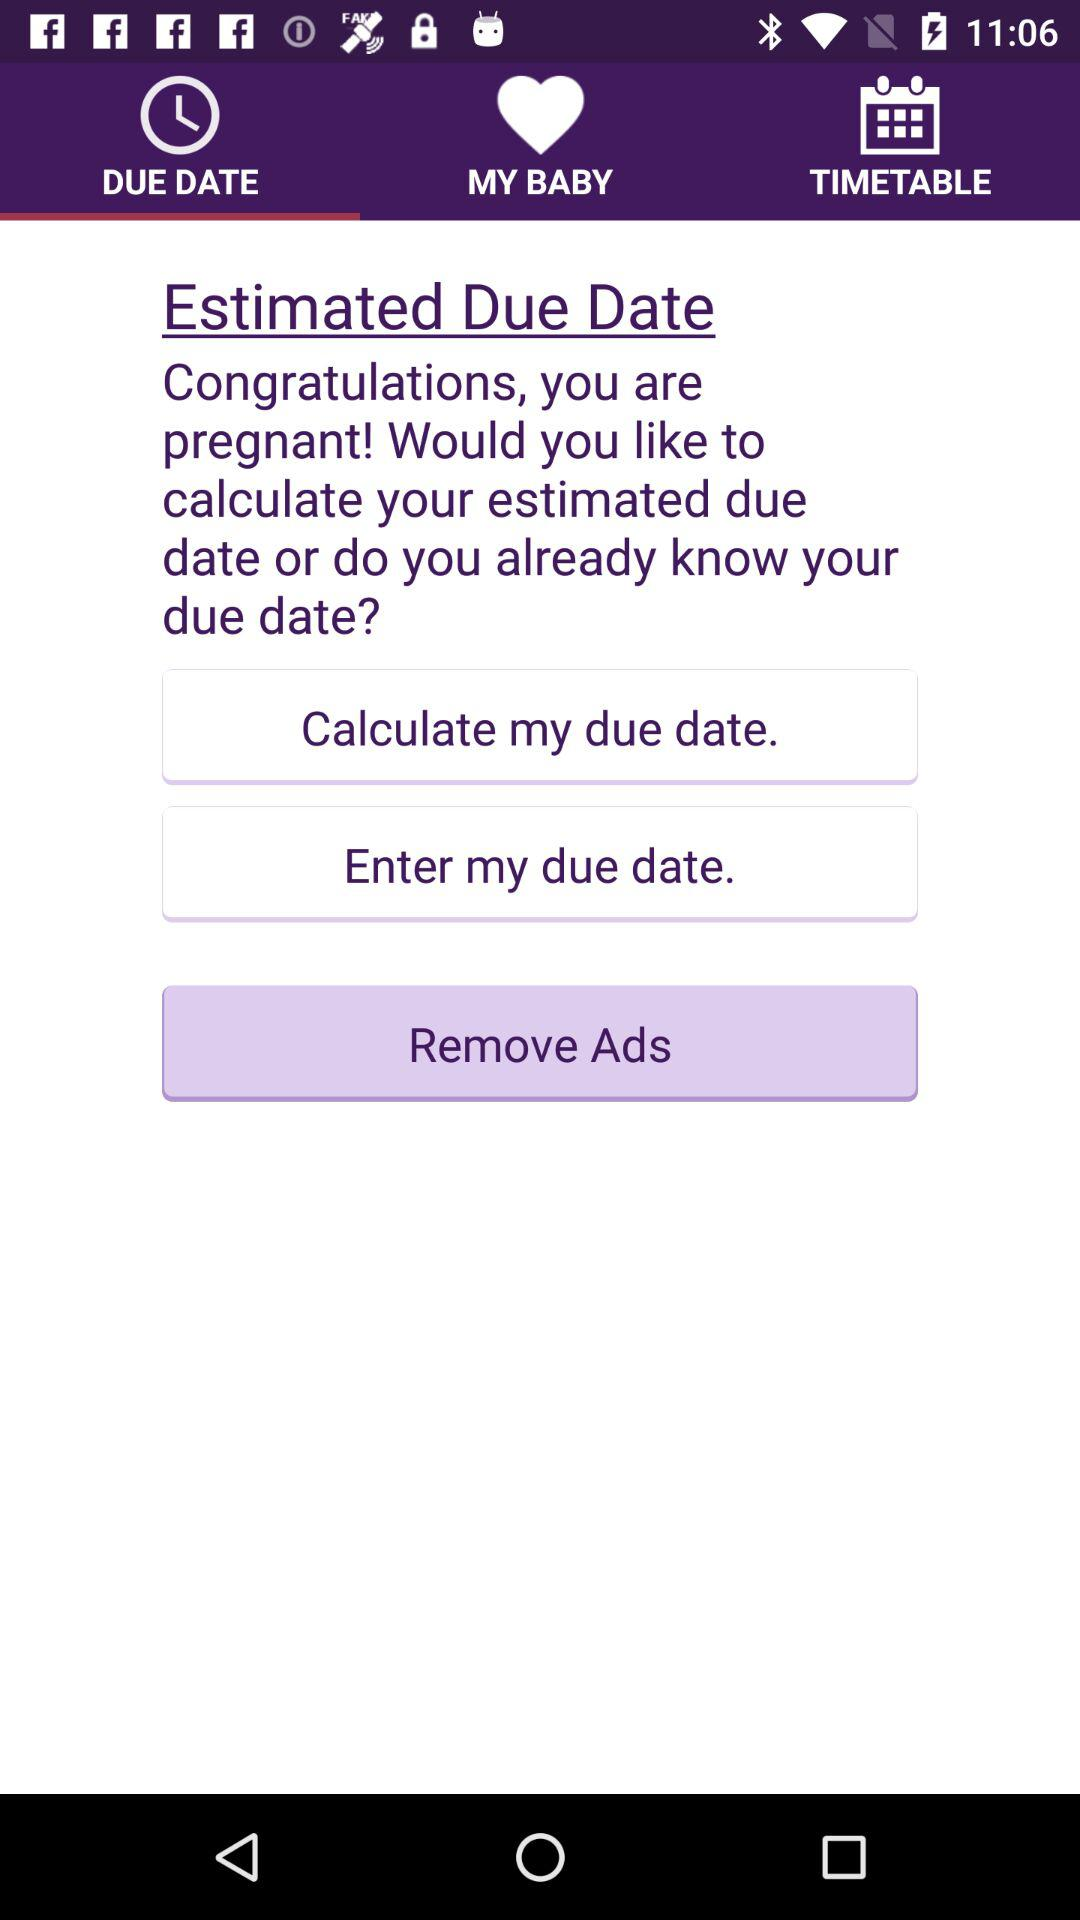What is the selected tab? The selected tab is "DUE DATE". 